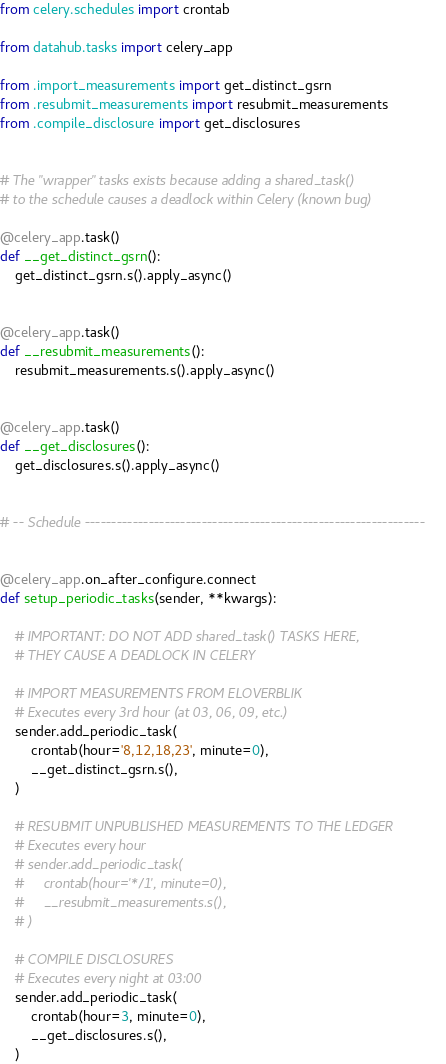Convert code to text. <code><loc_0><loc_0><loc_500><loc_500><_Python_>from celery.schedules import crontab

from datahub.tasks import celery_app

from .import_measurements import get_distinct_gsrn
from .resubmit_measurements import resubmit_measurements
from .compile_disclosure import get_disclosures


# The "wrapper" tasks exists because adding a shared_task()
# to the schedule causes a deadlock within Celery (known bug)

@celery_app.task()
def __get_distinct_gsrn():
    get_distinct_gsrn.s().apply_async()


@celery_app.task()
def __resubmit_measurements():
    resubmit_measurements.s().apply_async()


@celery_app.task()
def __get_disclosures():
    get_disclosures.s().apply_async()


# -- Schedule ----------------------------------------------------------------


@celery_app.on_after_configure.connect
def setup_periodic_tasks(sender, **kwargs):

    # IMPORTANT: DO NOT ADD shared_task() TASKS HERE,
    # THEY CAUSE A DEADLOCK IN CELERY

    # IMPORT MEASUREMENTS FROM ELOVERBLIK
    # Executes every 3rd hour (at 03, 06, 09, etc.)
    sender.add_periodic_task(
        crontab(hour='8,12,18,23', minute=0),
        __get_distinct_gsrn.s(),
    )

    # RESUBMIT UNPUBLISHED MEASUREMENTS TO THE LEDGER
    # Executes every hour
    # sender.add_periodic_task(
    #     crontab(hour='*/1', minute=0),
    #     __resubmit_measurements.s(),
    # )

    # COMPILE DISCLOSURES
    # Executes every night at 03:00
    sender.add_periodic_task(
        crontab(hour=3, minute=0),
        __get_disclosures.s(),
    )
</code> 